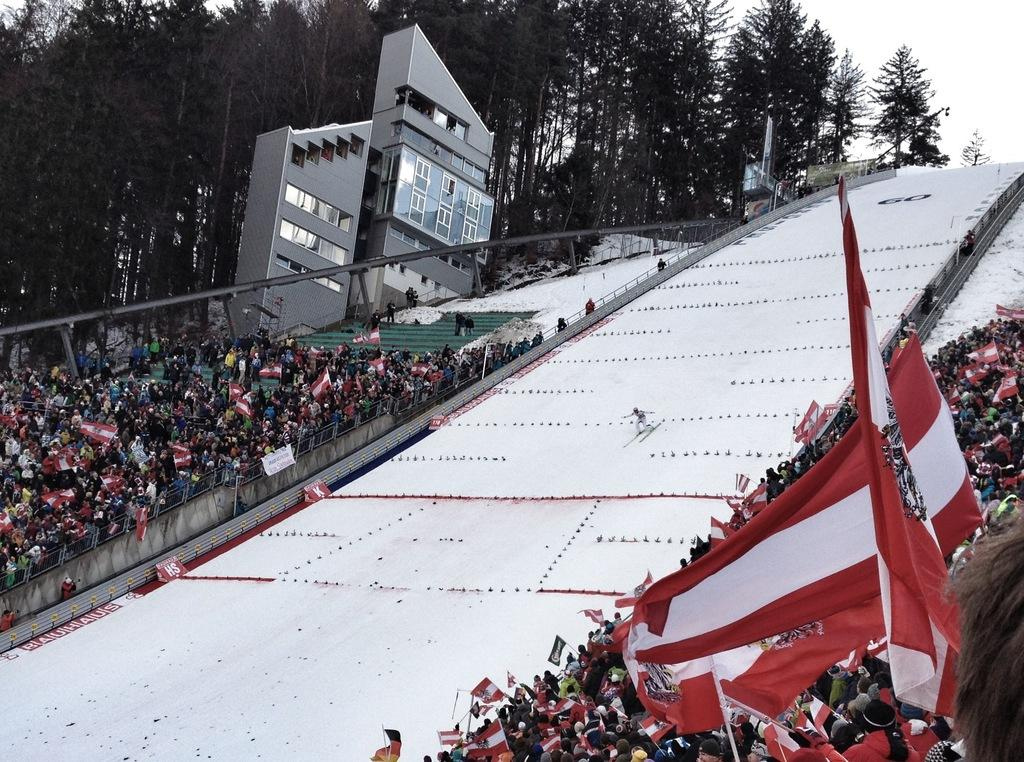What is the main subject of the image? The main subject of the image is a crowd. What can be seen in the image besides the crowd? There are flags, trees, a building, a banner, and a person skiing on the snow visible in the image. What is the sky's condition in the image? The sky is visible in the background of the image. What type of airport can be seen in the image? There is no airport present in the image. What kind of camp is set up in the image? There is no camp present in the image. 